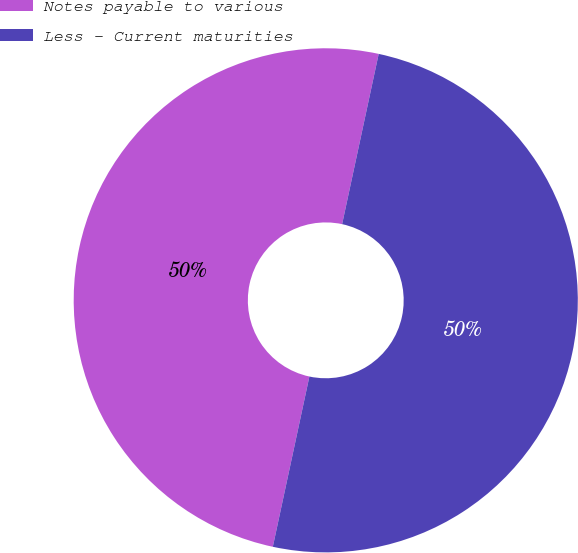<chart> <loc_0><loc_0><loc_500><loc_500><pie_chart><fcel>Notes payable to various<fcel>Less - Current maturities<nl><fcel>50.0%<fcel>50.0%<nl></chart> 